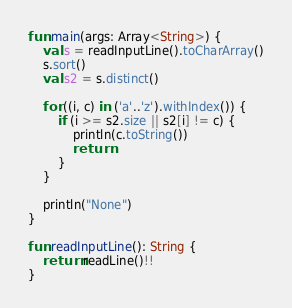Convert code to text. <code><loc_0><loc_0><loc_500><loc_500><_Kotlin_>fun main(args: Array<String>) {
    val s = readInputLine().toCharArray()
    s.sort()
    val s2 = s.distinct()

    for ((i, c) in ('a'..'z').withIndex()) {
        if (i >= s2.size || s2[i] != c) {
            println(c.toString())
            return
        }
    }

    println("None")
}
 
fun readInputLine(): String {
    return readLine()!!
}
</code> 